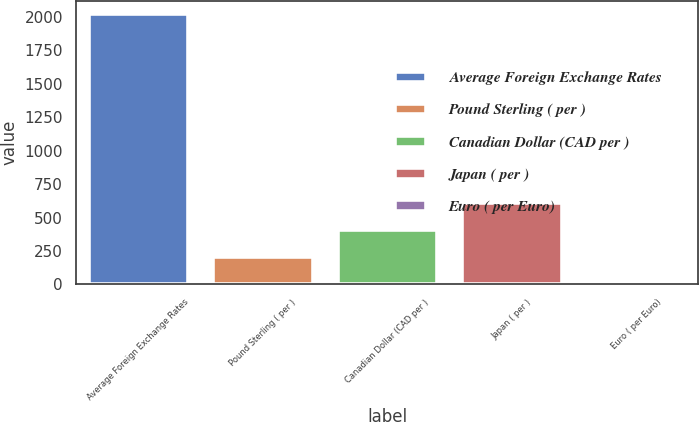Convert chart to OTSL. <chart><loc_0><loc_0><loc_500><loc_500><bar_chart><fcel>Average Foreign Exchange Rates<fcel>Pound Sterling ( per )<fcel>Canadian Dollar (CAD per )<fcel>Japan ( per )<fcel>Euro ( per Euro)<nl><fcel>2017<fcel>202.72<fcel>404.31<fcel>605.9<fcel>1.13<nl></chart> 